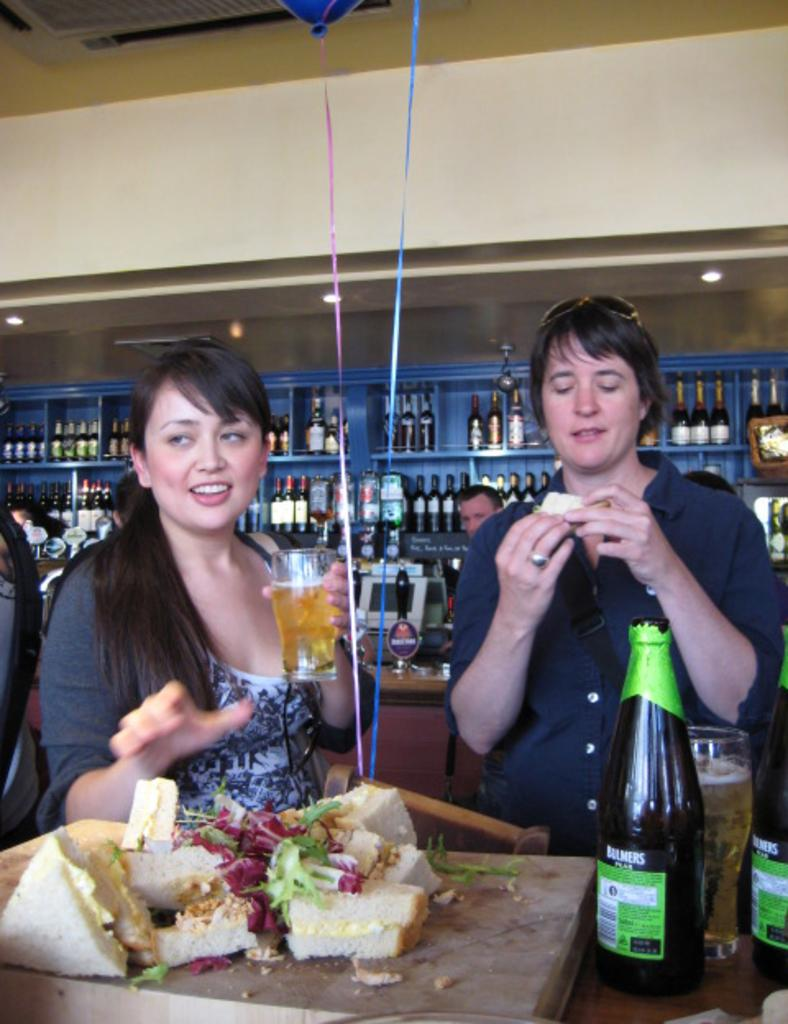<image>
Present a compact description of the photo's key features. A pair of large liquor bottles are labeled with the Bulmers brand name. 